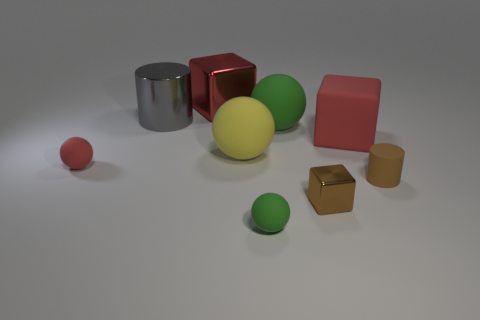Is the color of the small metal block the same as the tiny matte cylinder?
Your answer should be compact. Yes. Does the large cylinder have the same material as the tiny brown cube?
Make the answer very short. Yes. Are there an equal number of small blocks behind the large green ball and big green rubber spheres right of the small cube?
Keep it short and to the point. Yes. What number of small brown cylinders are on the right side of the red rubber block?
Your answer should be compact. 1. What number of things are gray matte cubes or shiny cylinders?
Make the answer very short. 1. How many matte cylinders have the same size as the metal cylinder?
Keep it short and to the point. 0. There is a shiny object in front of the large yellow matte thing on the left side of the tiny metal object; what is its shape?
Make the answer very short. Cube. Are there fewer brown matte cylinders than tiny cyan metal spheres?
Your answer should be compact. No. The shiny object that is in front of the big red rubber thing is what color?
Your answer should be very brief. Brown. There is a thing that is in front of the gray metal object and behind the big red matte block; what is its material?
Provide a succinct answer. Rubber. 